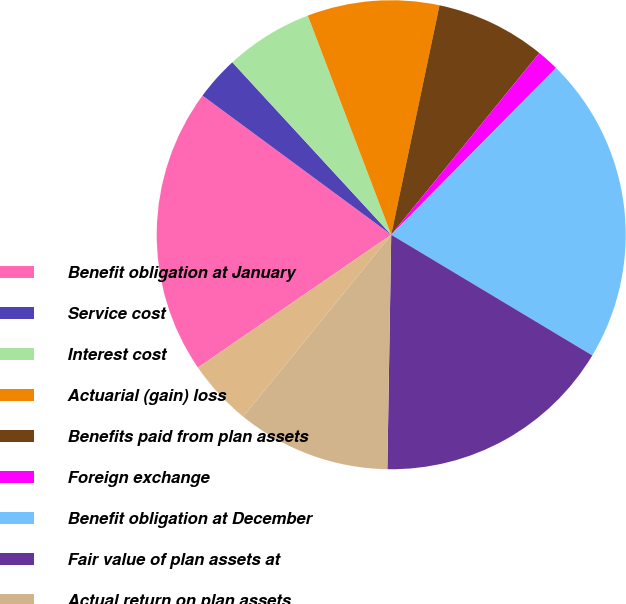<chart> <loc_0><loc_0><loc_500><loc_500><pie_chart><fcel>Benefit obligation at January<fcel>Service cost<fcel>Interest cost<fcel>Actuarial (gain) loss<fcel>Benefits paid from plan assets<fcel>Foreign exchange<fcel>Benefit obligation at December<fcel>Fair value of plan assets at<fcel>Actual return on plan assets<fcel>Company contributions<nl><fcel>19.69%<fcel>3.04%<fcel>6.06%<fcel>9.09%<fcel>7.58%<fcel>1.52%<fcel>21.2%<fcel>16.66%<fcel>10.61%<fcel>4.55%<nl></chart> 